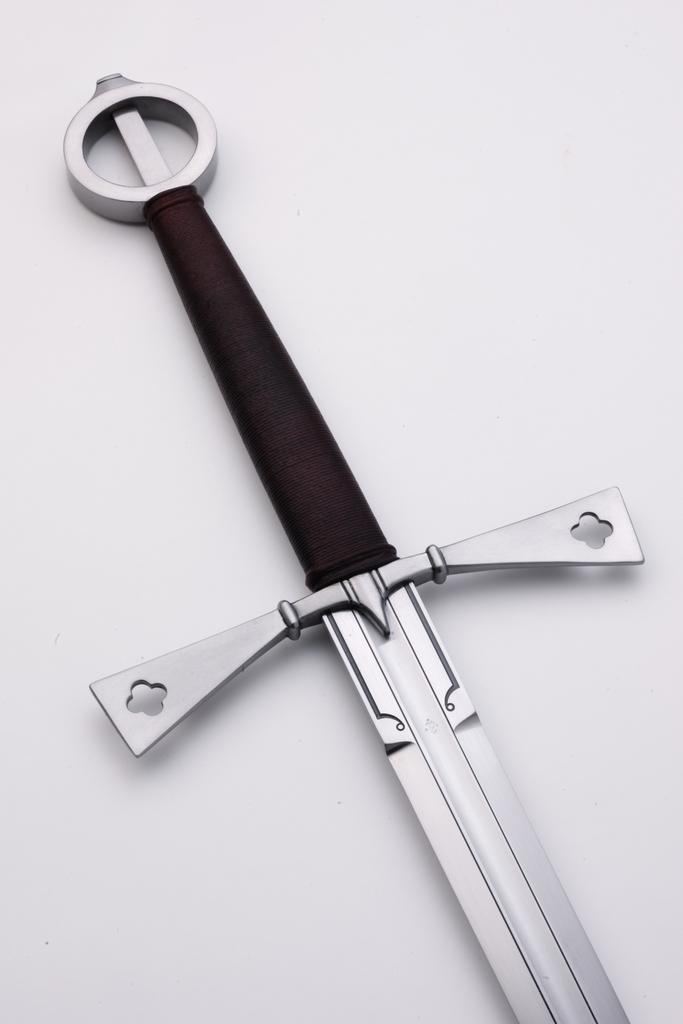What object can be seen in the image? There is a sword in the image. Where is the sword located? The sword is on a surface. Can you describe the different parts of the sword? The pommel is at the top of the sword, the guard is in the center, and the grip is between the pommel and the guard. What type of hen is sitting on the record in the image? There is no hen or record present in the image; it only features a sword. 